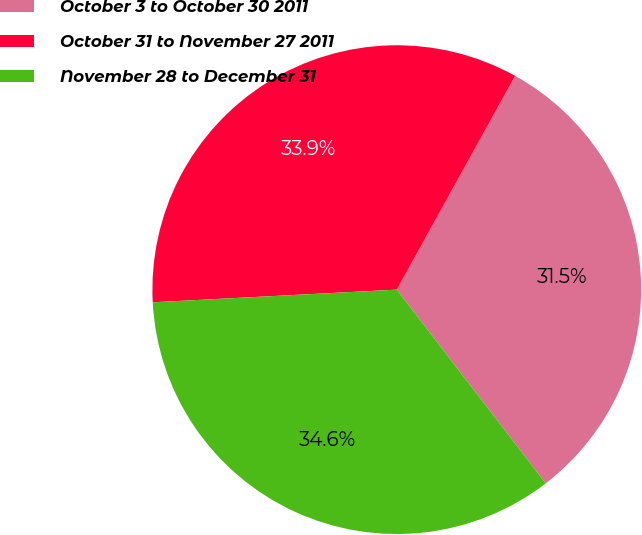Convert chart. <chart><loc_0><loc_0><loc_500><loc_500><pie_chart><fcel>October 3 to October 30 2011<fcel>October 31 to November 27 2011<fcel>November 28 to December 31<nl><fcel>31.52%<fcel>33.87%<fcel>34.61%<nl></chart> 